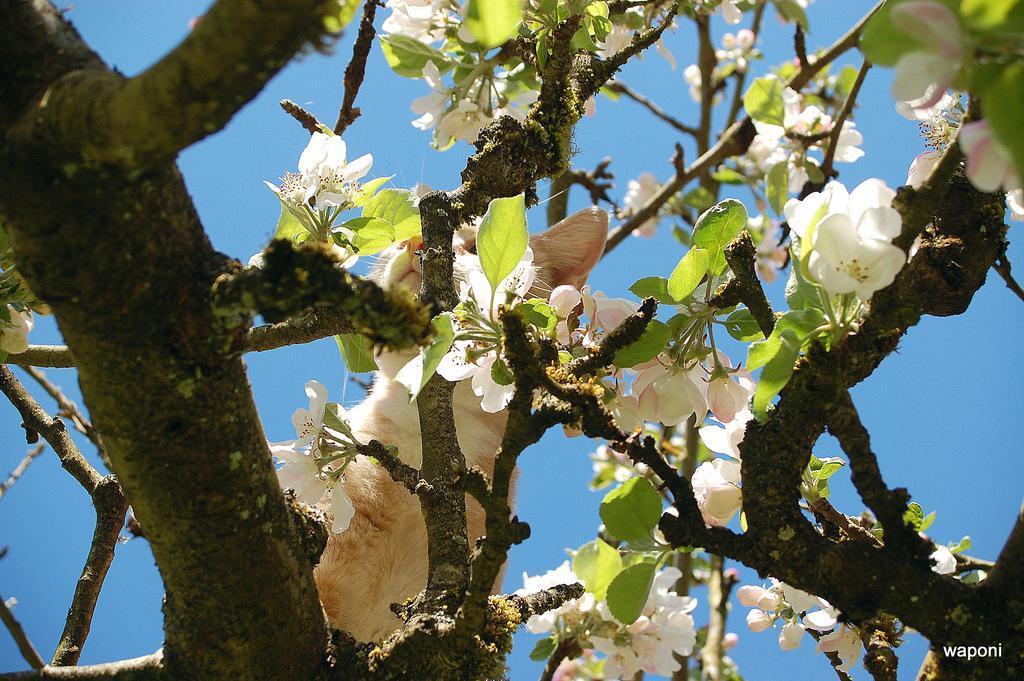Please provide a concise description of this image. In this image I can see a cat on a tree. I can also see white color flowers on the tree. In the background I can see the sky. Here I can see a watermark. 